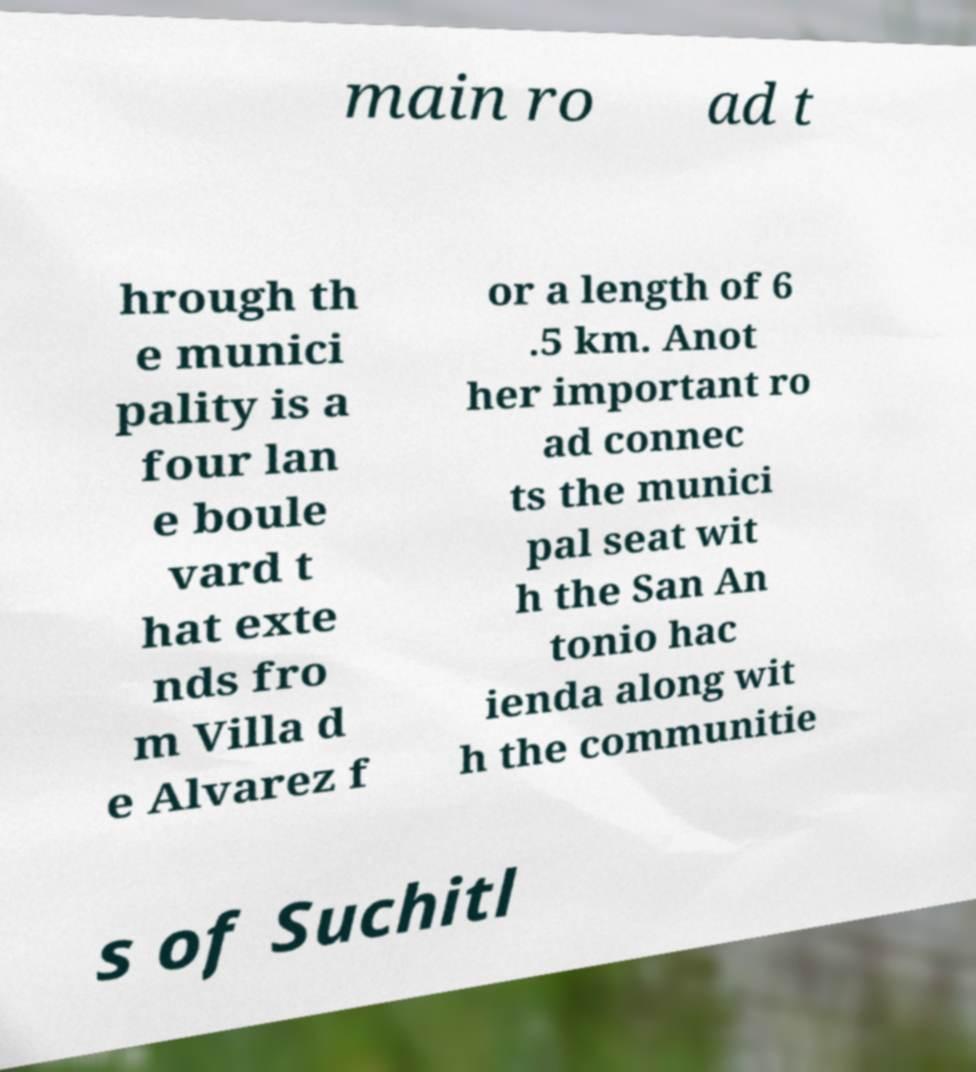Can you read and provide the text displayed in the image?This photo seems to have some interesting text. Can you extract and type it out for me? main ro ad t hrough th e munici pality is a four lan e boule vard t hat exte nds fro m Villa d e Alvarez f or a length of 6 .5 km. Anot her important ro ad connec ts the munici pal seat wit h the San An tonio hac ienda along wit h the communitie s of Suchitl 